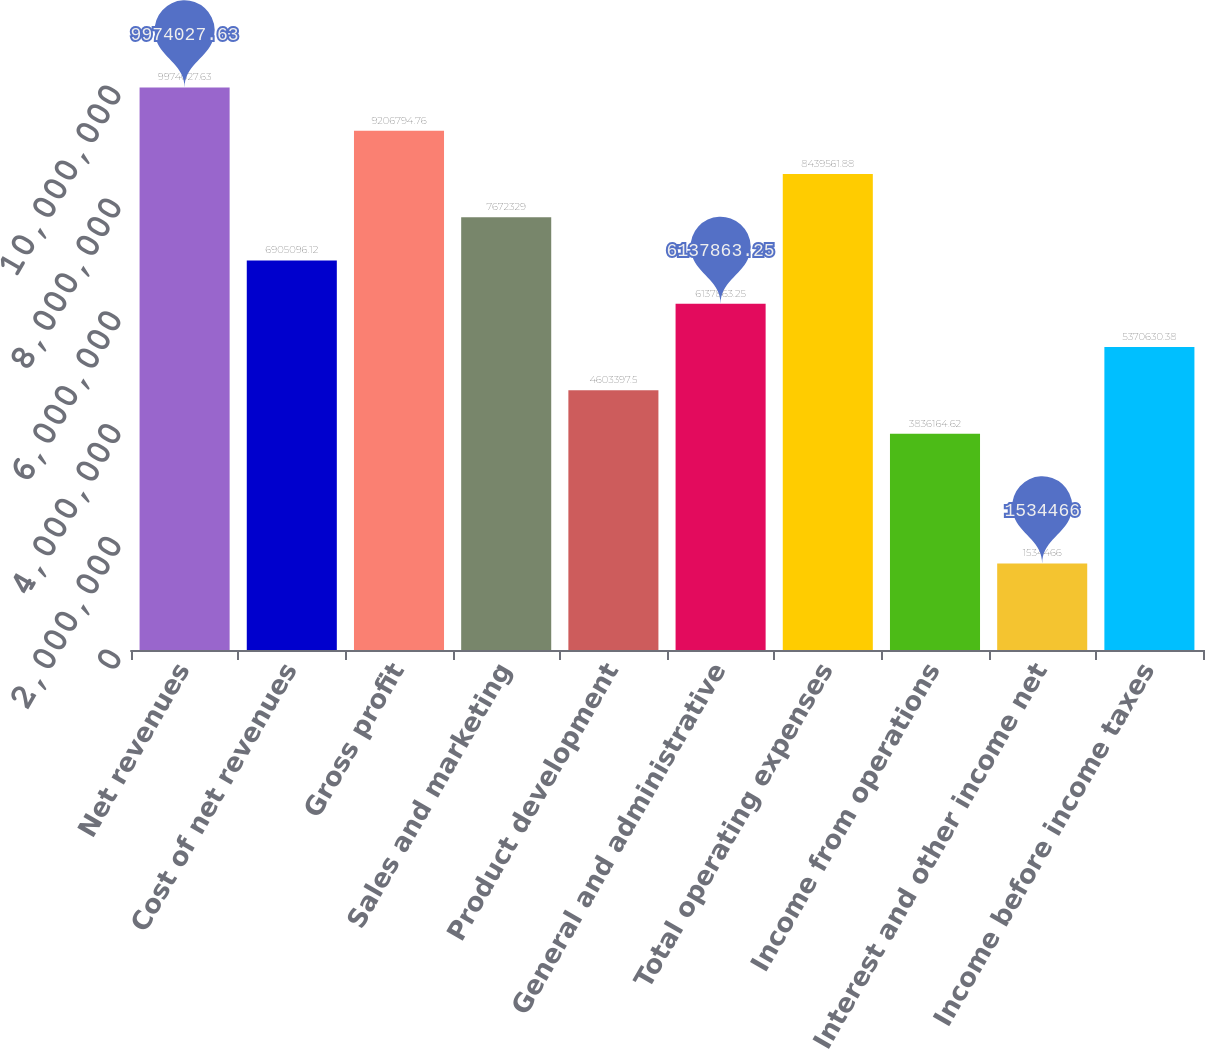Convert chart. <chart><loc_0><loc_0><loc_500><loc_500><bar_chart><fcel>Net revenues<fcel>Cost of net revenues<fcel>Gross profit<fcel>Sales and marketing<fcel>Product development<fcel>General and administrative<fcel>Total operating expenses<fcel>Income from operations<fcel>Interest and other income net<fcel>Income before income taxes<nl><fcel>9.97403e+06<fcel>6.9051e+06<fcel>9.20679e+06<fcel>7.67233e+06<fcel>4.6034e+06<fcel>6.13786e+06<fcel>8.43956e+06<fcel>3.83616e+06<fcel>1.53447e+06<fcel>5.37063e+06<nl></chart> 